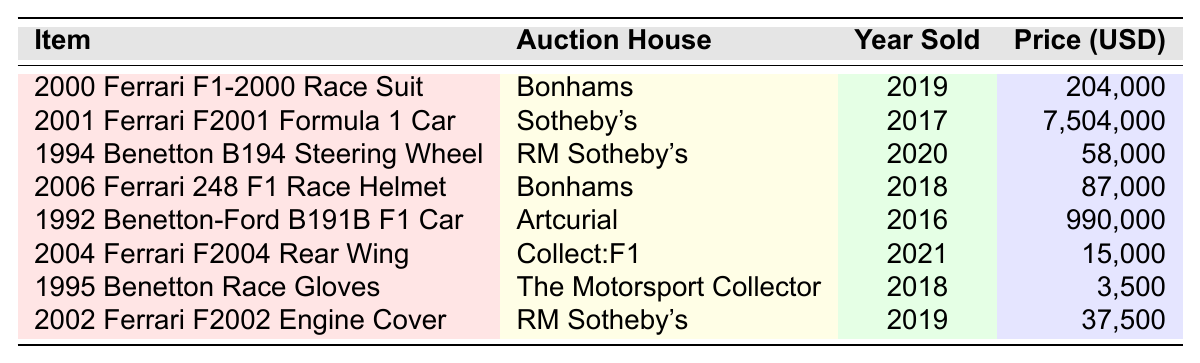What is the most expensive Michael Schumacher memorabilia item sold? The item listed with the highest auction price is the "2001 Ferrari F2001 Formula 1 Car," sold for 7,504,000 USD.
Answer: 2001 Ferrari F2001 Formula 1 Car In which year was the "2000 Ferrari F1-2000 Race Suit" sold? The table shows that the "2000 Ferrari F1-2000 Race Suit" was sold in 2019.
Answer: 2019 What is the auction house that sold the "1994 Benetton B194 Steering Wheel"? According to the table, the "1994 Benetton B194 Steering Wheel" was sold by RM Sotheby's.
Answer: RM Sotheby's How much did the "2004 Ferrari F2004 Rear Wing" sell for? The table indicates that the "2004 Ferrari F2004 Rear Wing" sold for 15,000 USD.
Answer: 15,000 USD What is the difference in auction price between the "1992 Benetton-Ford B191B F1 Car" and the "1995 Benetton Race Gloves"? The price of the "1992 Benetton-Ford B191B F1 Car" is 990,000 USD and the "1995 Benetton Race Gloves" is 3,500 USD. The difference is 990,000 - 3,500 = 986,500 USD.
Answer: 986,500 USD Which item was sold for a price closest to 90,000 USD? The auction prices near 90,000 USD are the "2006 Ferrari 248 F1 Race Helmet" at 87,000 USD and the "1994 Benetton B194 Steering Wheel" at 58,000 USD. Of these, the "2006 Ferrari 248 F1 Race Helmet" is the closest.
Answer: 2006 Ferrari 248 F1 Race Helmet What is the average price of all listed memorabilia items? To find the average, we sum all the prices: (204,000 + 7,504,000 + 58,000 + 87,000 + 990,000 + 15,000 + 3,500 + 37,500) = 8,899,000. There are 8 items, so the average is 8,899,000/8 = 1,112,375.
Answer: 1,112,375 USD Are all the memorabilia items sold at Bonhams from the same year? The "2000 Ferrari F1-2000 Race Suit" was sold in 2019, and the "2006 Ferrari 248 F1 Race Helmet" was sold in 2018. Since they are from different years, the answer is no.
Answer: No How many memorabilia items sold for more than 100,000 USD? The items that sold for more than 100,000 USD are the "2001 Ferrari F2001 Formula 1 Car" and the "1992 Benetton-Ford B191B F1 Car." This makes a total of 2 items.
Answer: 2 